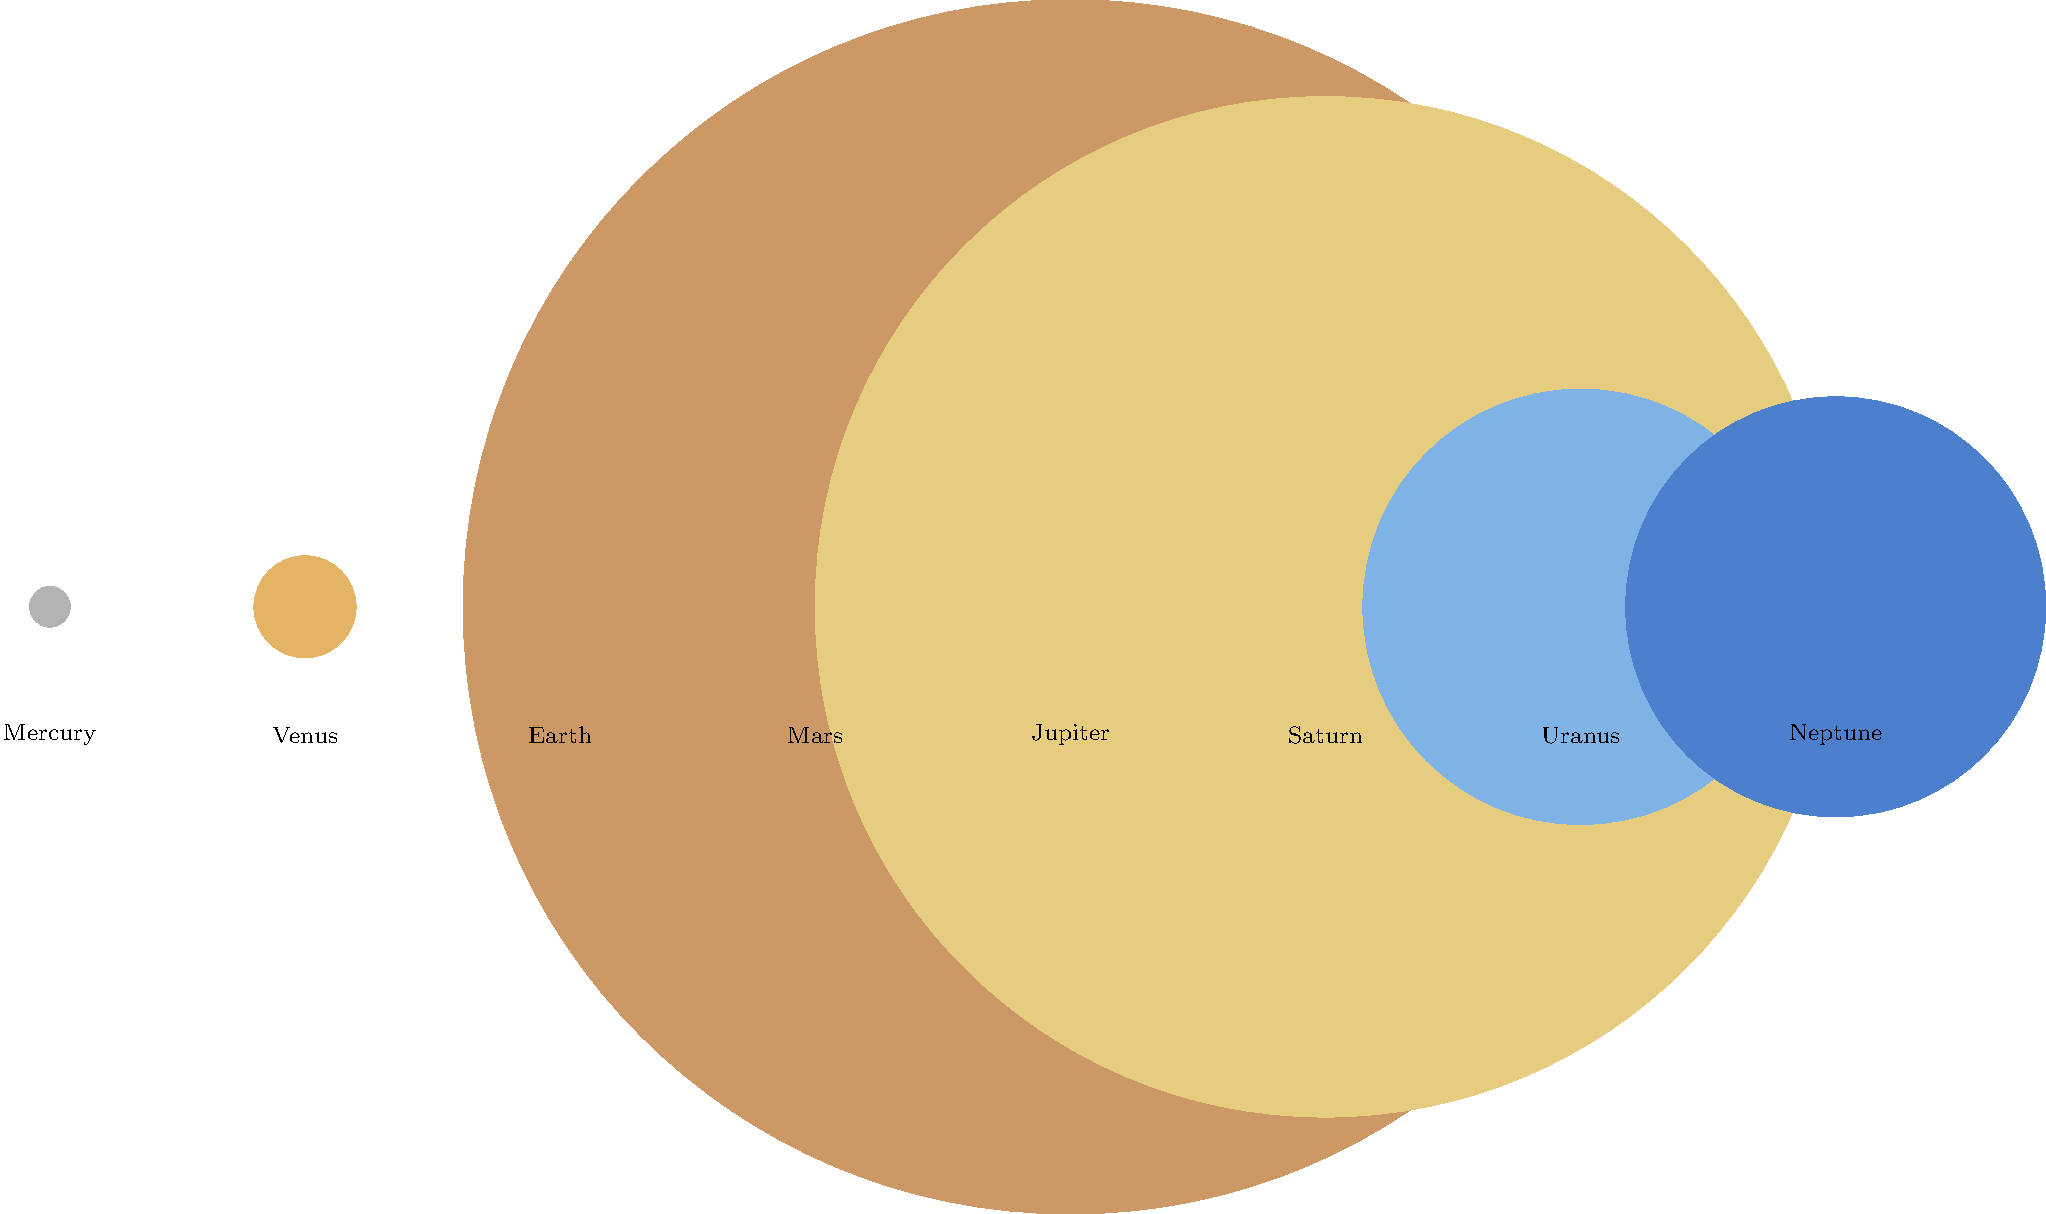As a communications expert, you are tasked with creating a visual representation of the relative sizes of planets in our solar system for a public outreach campaign. Using the provided graphic, which planet appears to be the largest, and approximately how many times larger is its diameter compared to Earth's? To answer this question, we need to analyze the graphic and compare the sizes of the planets:

1. Observe that the planets are represented by circles of different sizes.
2. Identify the largest circle in the graphic, which represents Jupiter.
3. Locate Earth's circle, which is the third from the left.
4. Compare the diameters of Jupiter and Earth visually.
5. Estimate the ratio of Jupiter's diameter to Earth's:
   - Jupiter's circle appears to be about 11-12 times wider than Earth's circle.
6. Verify this estimation using the actual relative sizes:
   - Jupiter's radius in the graphic: 7.14 units
   - Earth's radius in the graphic: 0.63 units
   - Ratio of radii: $\frac{7.14}{0.63} \approx 11.33$

This ratio represents the relative diameters of the planets, as the diameter is twice the radius for both planets, and the factor of 2 cancels out in the ratio.

The calculated ratio of approximately 11.33 confirms our visual estimation that Jupiter appears about 11-12 times larger than Earth in diameter.
Answer: Jupiter; approximately 11 times larger 